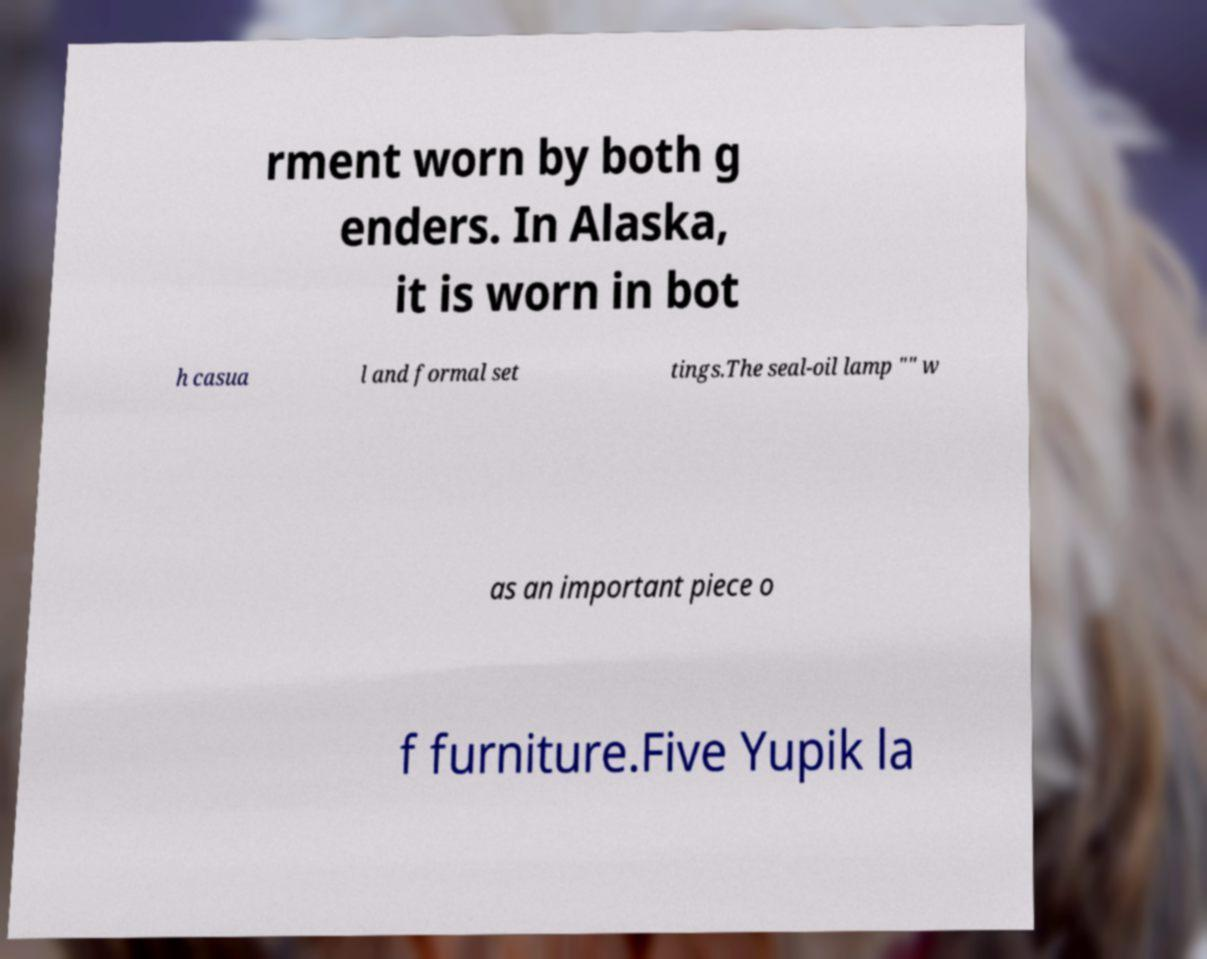Could you extract and type out the text from this image? rment worn by both g enders. In Alaska, it is worn in bot h casua l and formal set tings.The seal-oil lamp "" w as an important piece o f furniture.Five Yupik la 